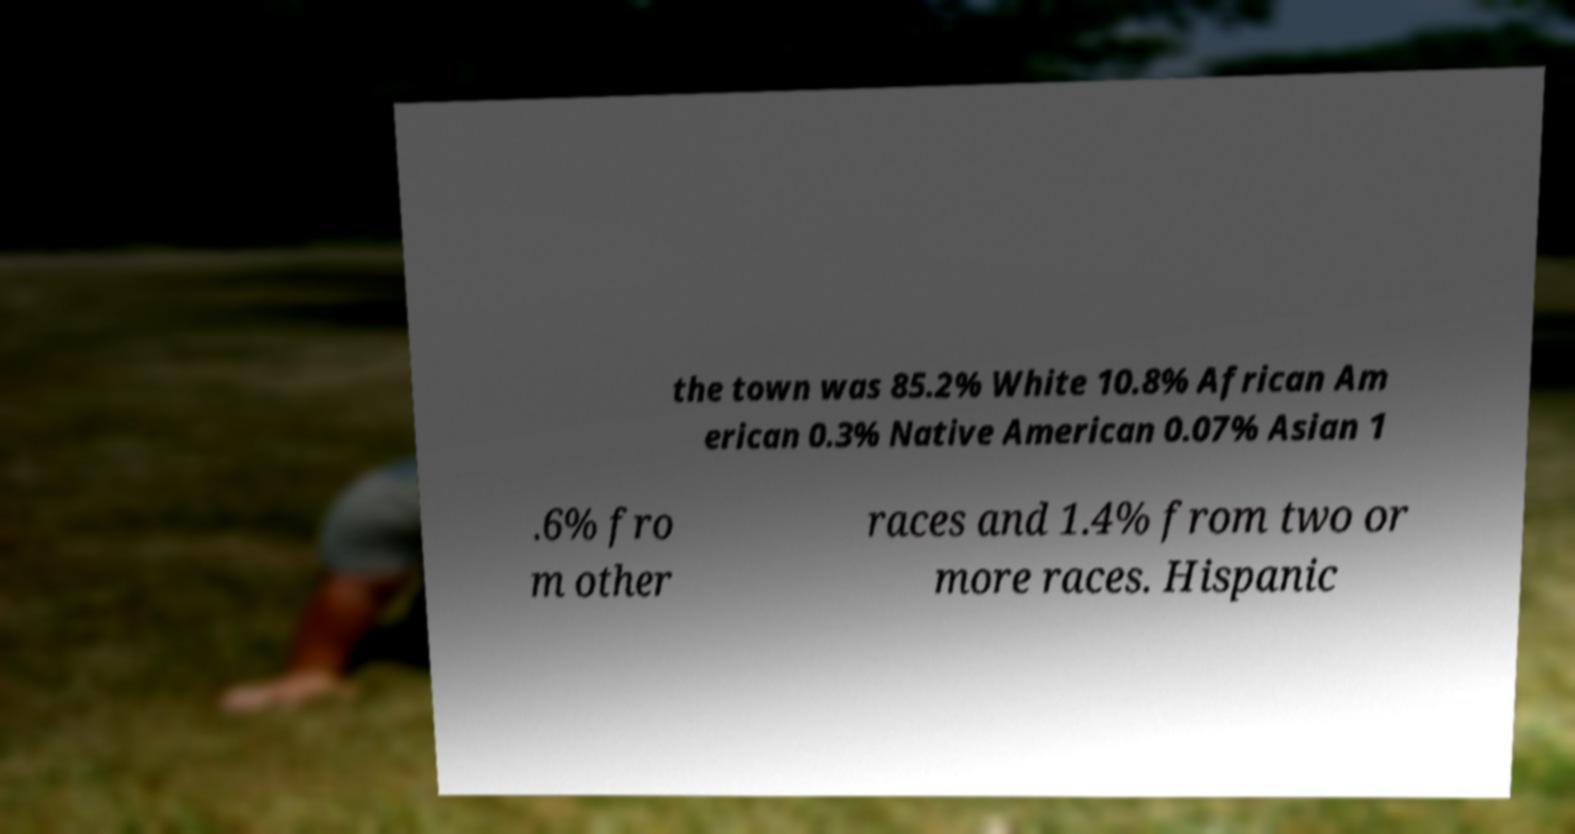Could you assist in decoding the text presented in this image and type it out clearly? the town was 85.2% White 10.8% African Am erican 0.3% Native American 0.07% Asian 1 .6% fro m other races and 1.4% from two or more races. Hispanic 